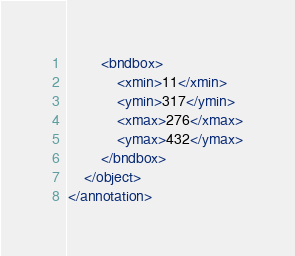<code> <loc_0><loc_0><loc_500><loc_500><_XML_>		<bndbox>
			<xmin>11</xmin>
			<ymin>317</ymin>
			<xmax>276</xmax>
			<ymax>432</ymax>
		</bndbox>
	</object>
</annotation>
</code> 